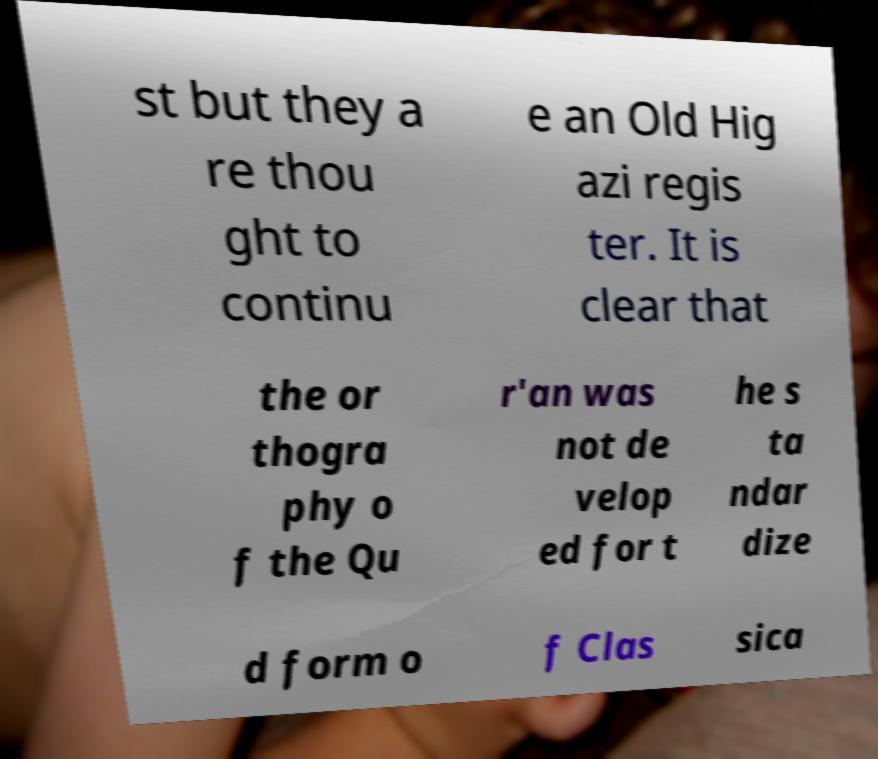For documentation purposes, I need the text within this image transcribed. Could you provide that? st but they a re thou ght to continu e an Old Hig azi regis ter. It is clear that the or thogra phy o f the Qu r'an was not de velop ed for t he s ta ndar dize d form o f Clas sica 